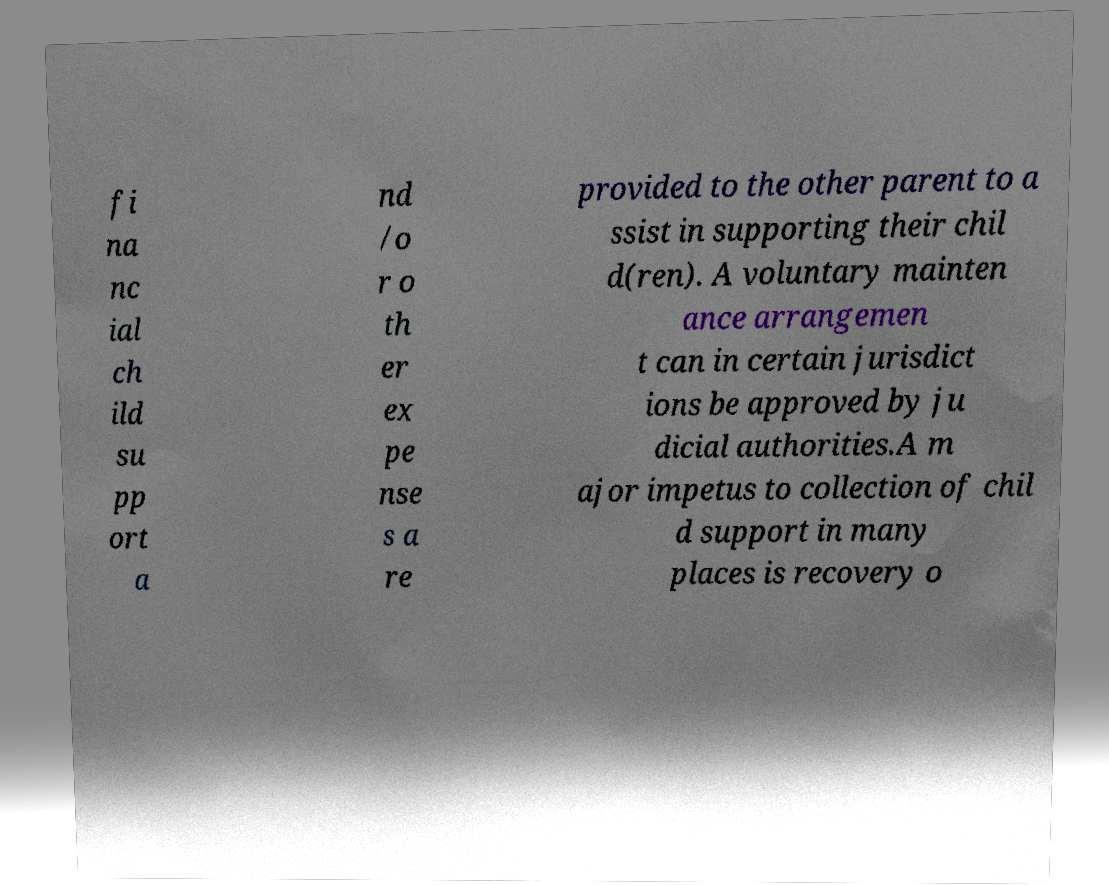There's text embedded in this image that I need extracted. Can you transcribe it verbatim? fi na nc ial ch ild su pp ort a nd /o r o th er ex pe nse s a re provided to the other parent to a ssist in supporting their chil d(ren). A voluntary mainten ance arrangemen t can in certain jurisdict ions be approved by ju dicial authorities.A m ajor impetus to collection of chil d support in many places is recovery o 